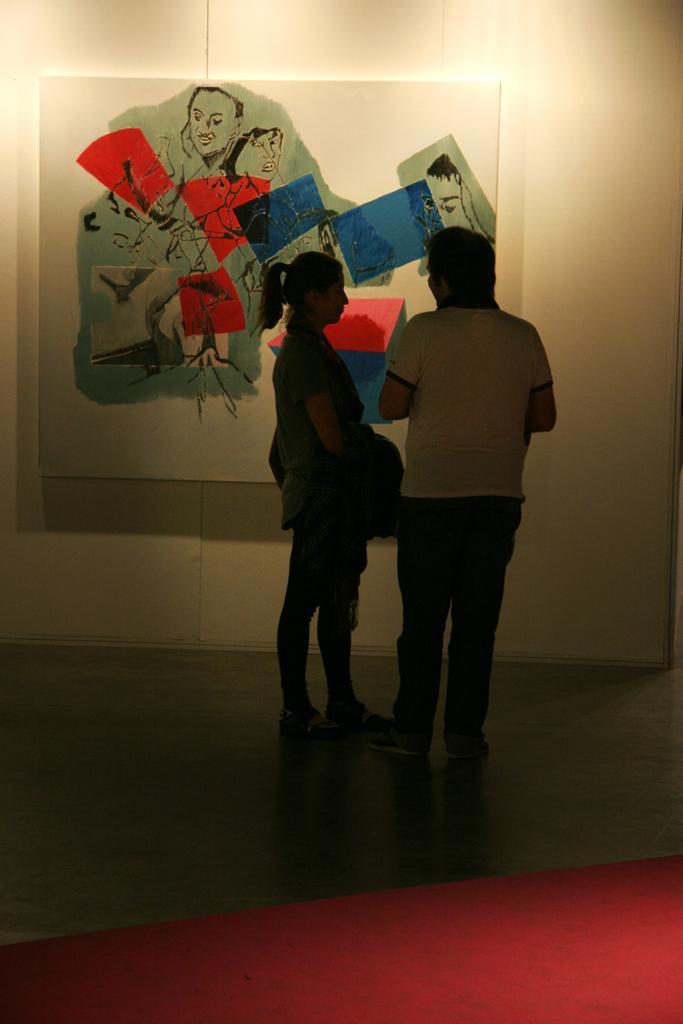Can you describe this image briefly? In this picture there are two people standing. At the back there is a board on the wall. There is a painting on the board. At the bottom it looks like a carpet on the floor. 